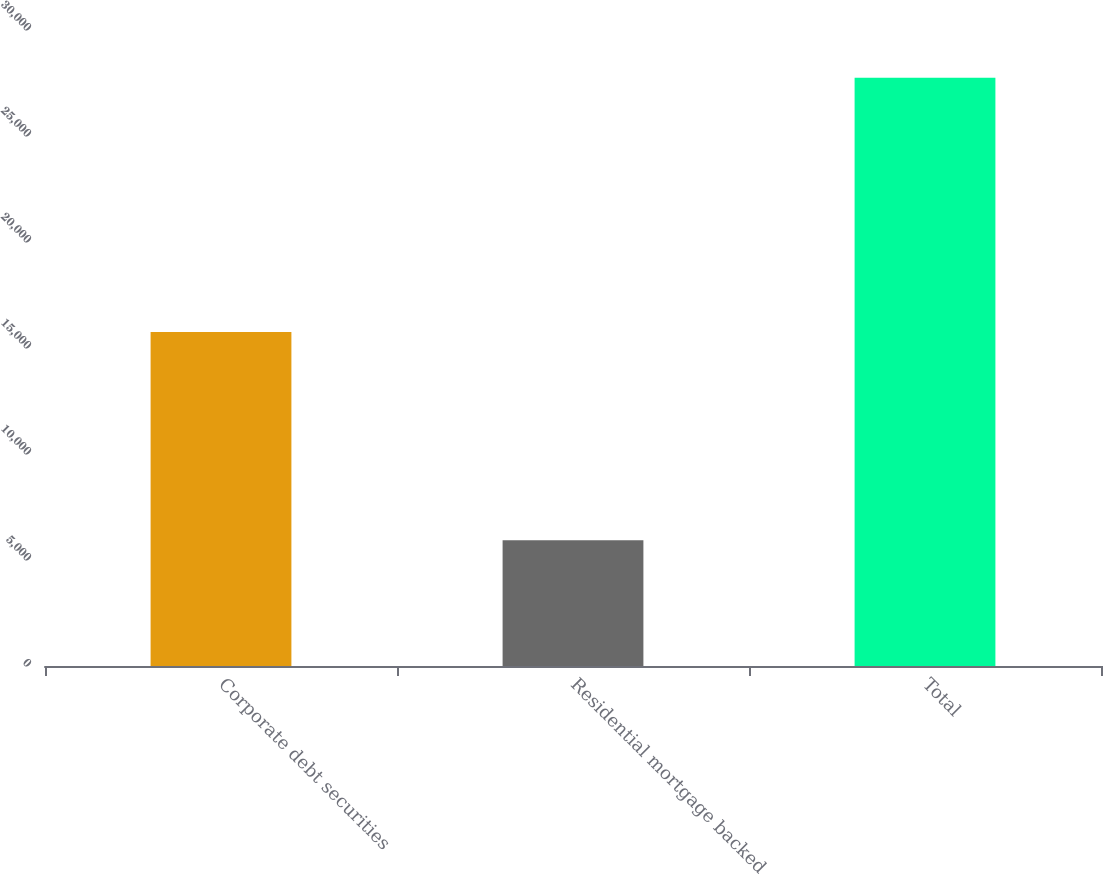<chart> <loc_0><loc_0><loc_500><loc_500><bar_chart><fcel>Corporate debt securities<fcel>Residential mortgage backed<fcel>Total<nl><fcel>15750<fcel>5933<fcel>27752<nl></chart> 